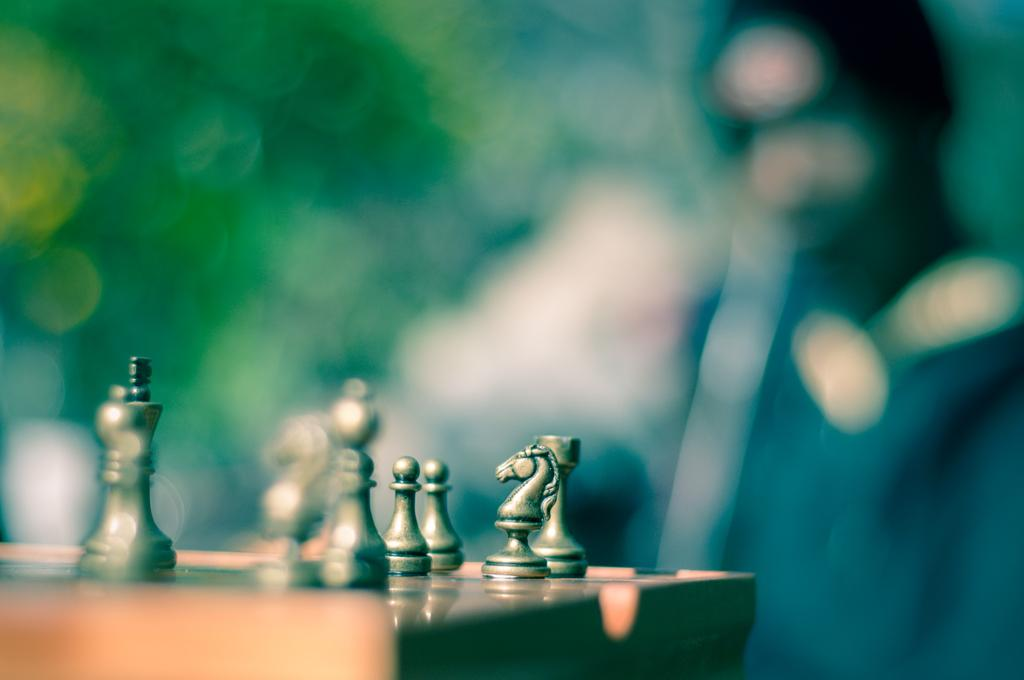What is on the table in the image? There are chess coins on a table in the image. Can you describe the background of the image? The background of the image is blurry. Is there anyone visible in the image? Yes, there is a person on the right side of the image. What type of test is being conducted in the image? There is no test being conducted in the image; it features chess coins on a table and a person on the right side. Can you describe the yard in the image? There is no yard present in the image; it is focused on the table and the person. 